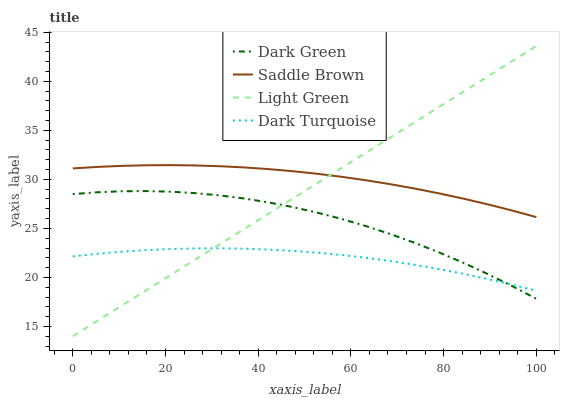Does Dark Turquoise have the minimum area under the curve?
Answer yes or no. Yes. Does Saddle Brown have the maximum area under the curve?
Answer yes or no. Yes. Does Light Green have the minimum area under the curve?
Answer yes or no. No. Does Light Green have the maximum area under the curve?
Answer yes or no. No. Is Light Green the smoothest?
Answer yes or no. Yes. Is Dark Green the roughest?
Answer yes or no. Yes. Is Saddle Brown the smoothest?
Answer yes or no. No. Is Saddle Brown the roughest?
Answer yes or no. No. Does Light Green have the lowest value?
Answer yes or no. Yes. Does Saddle Brown have the lowest value?
Answer yes or no. No. Does Light Green have the highest value?
Answer yes or no. Yes. Does Saddle Brown have the highest value?
Answer yes or no. No. Is Dark Green less than Saddle Brown?
Answer yes or no. Yes. Is Saddle Brown greater than Dark Green?
Answer yes or no. Yes. Does Dark Turquoise intersect Dark Green?
Answer yes or no. Yes. Is Dark Turquoise less than Dark Green?
Answer yes or no. No. Is Dark Turquoise greater than Dark Green?
Answer yes or no. No. Does Dark Green intersect Saddle Brown?
Answer yes or no. No. 